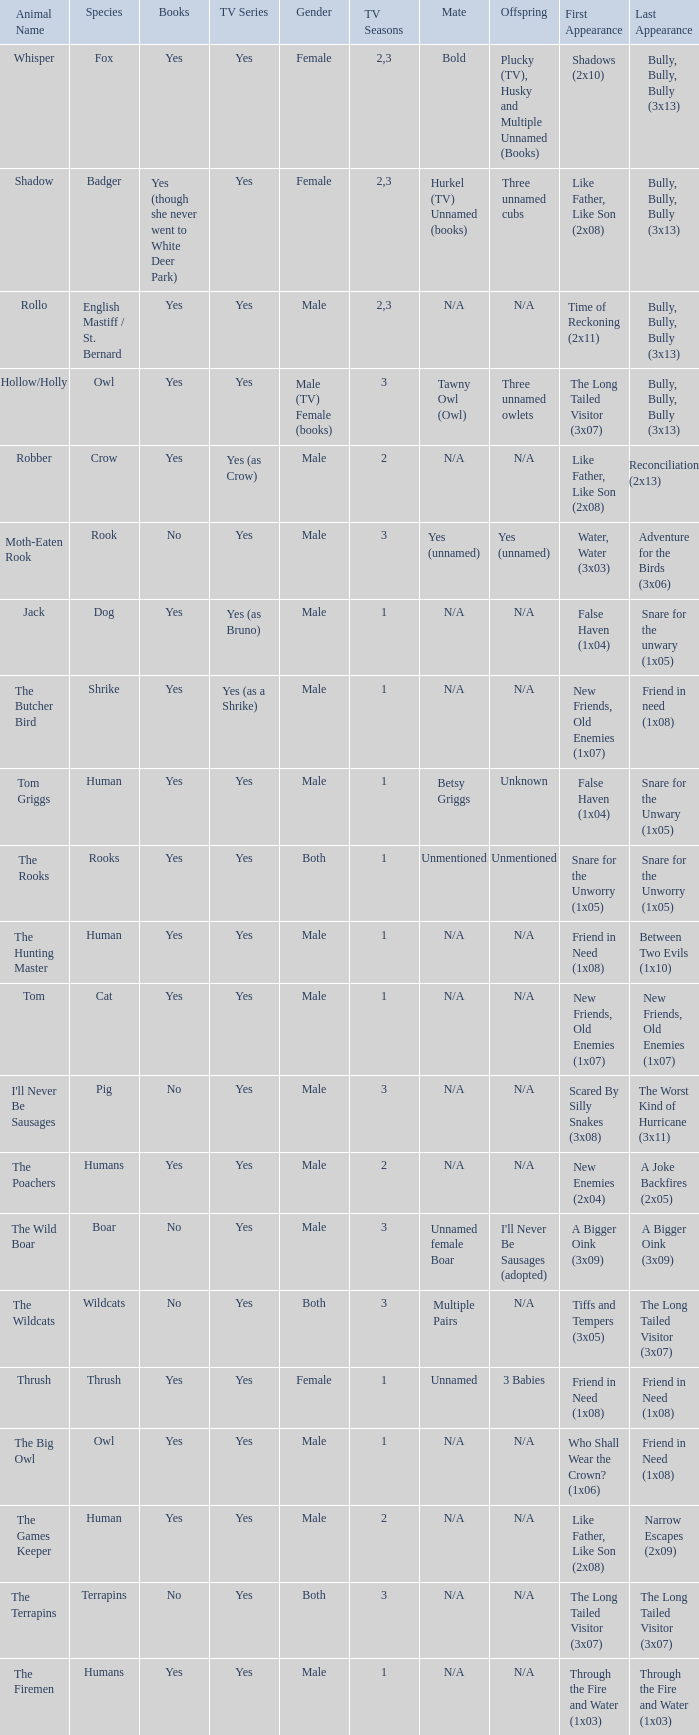What is the smallest season for a tv series with a yes and human was the species? 1.0. 